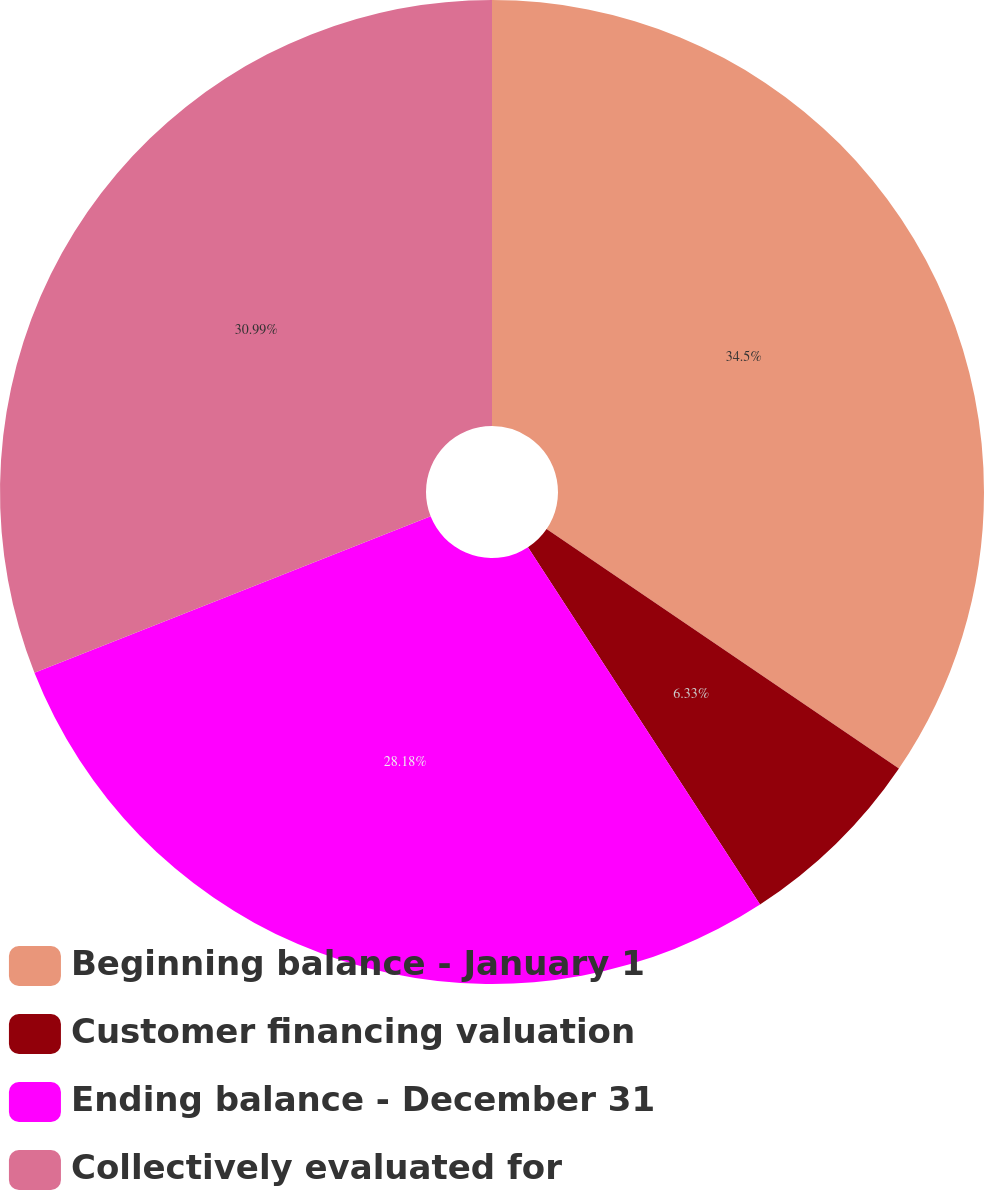Convert chart to OTSL. <chart><loc_0><loc_0><loc_500><loc_500><pie_chart><fcel>Beginning balance - January 1<fcel>Customer financing valuation<fcel>Ending balance - December 31<fcel>Collectively evaluated for<nl><fcel>34.5%<fcel>6.33%<fcel>28.18%<fcel>30.99%<nl></chart> 